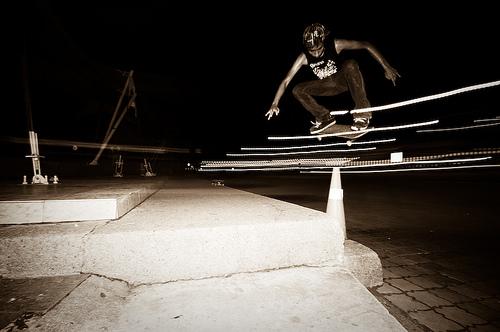What type of photography is this?
Concise answer only. Action. Is the man's shirt sleeveless?
Keep it brief. Yes. Is the man moving through the air?
Be succinct. Yes. 